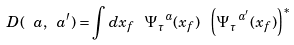<formula> <loc_0><loc_0><loc_500><loc_500>D ( \ a , \ a ^ { \prime } ) = \int d x _ { f } \ \Psi ^ { \ a } _ { \tau } ( x _ { f } ) \ \left ( \Psi ^ { \ a ^ { \prime } } _ { \tau } ( x _ { f } ) \right ) ^ { * }</formula> 